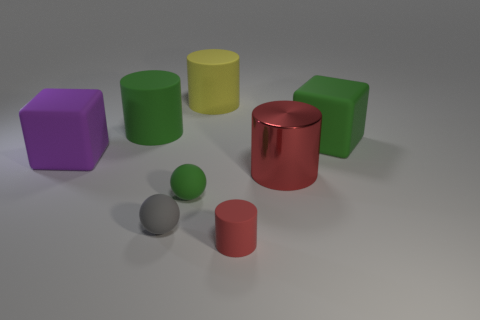There is another red thing that is the same shape as the tiny red matte object; what is it made of?
Your response must be concise. Metal. There is a tiny matte cylinder; is its color the same as the large object that is in front of the large purple block?
Offer a terse response. Yes. The large cylinder in front of the green thing on the right side of the matte cylinder that is in front of the green matte cube is made of what material?
Offer a terse response. Metal. What number of other things are there of the same size as the purple object?
Your response must be concise. 4. What size is the metallic cylinder that is the same color as the small matte cylinder?
Keep it short and to the point. Large. Is the number of large green cylinders that are to the left of the tiny gray sphere greater than the number of blue matte cylinders?
Provide a succinct answer. Yes. Is there a large metal cylinder that has the same color as the tiny rubber cylinder?
Provide a succinct answer. Yes. The other metal cylinder that is the same size as the green cylinder is what color?
Your answer should be compact. Red. There is a ball that is to the left of the tiny green object; how many matte things are right of it?
Offer a terse response. 4. How many things are either large cylinders that are on the right side of the small gray ball or tiny gray balls?
Your response must be concise. 3. 